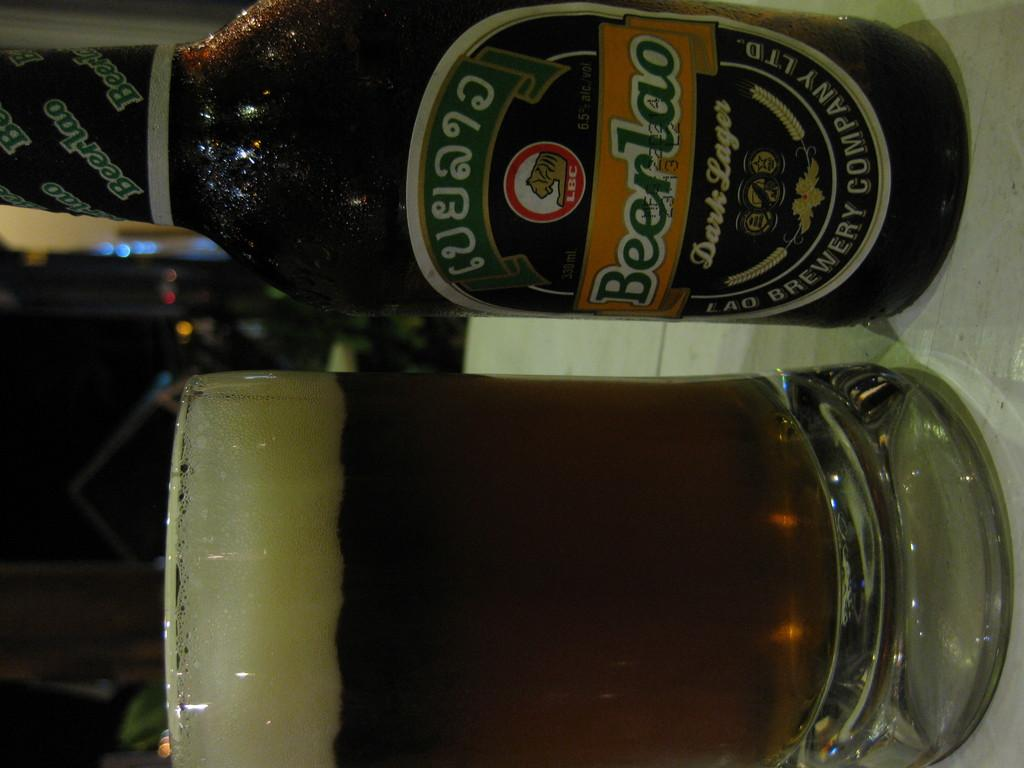<image>
Share a concise interpretation of the image provided. Beerlao Dark Lager is printed on the side of this bottle. 